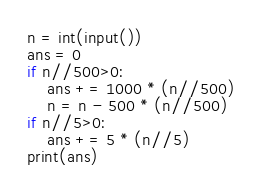Convert code to text. <code><loc_0><loc_0><loc_500><loc_500><_Python_>n = int(input())
ans = 0
if n//500>0:
    ans += 1000 * (n//500)
    n = n - 500 * (n//500)
if n//5>0:
    ans += 5 * (n//5)
print(ans)</code> 